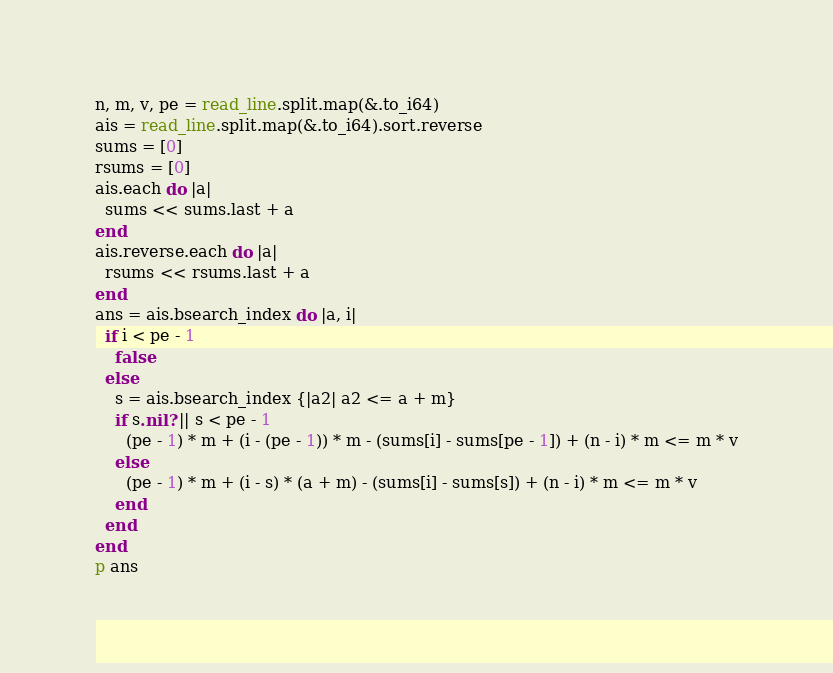<code> <loc_0><loc_0><loc_500><loc_500><_Crystal_>n, m, v, pe = read_line.split.map(&.to_i64)
ais = read_line.split.map(&.to_i64).sort.reverse
sums = [0]
rsums = [0]
ais.each do |a|
  sums << sums.last + a
end
ais.reverse.each do |a|
  rsums << rsums.last + a
end
ans = ais.bsearch_index do |a, i|
  if i < pe - 1
    false
  else
    s = ais.bsearch_index {|a2| a2 <= a + m}
    if s.nil? || s < pe - 1
      (pe - 1) * m + (i - (pe - 1)) * m - (sums[i] - sums[pe - 1]) + (n - i) * m <= m * v
    else
      (pe - 1) * m + (i - s) * (a + m) - (sums[i] - sums[s]) + (n - i) * m <= m * v
    end
  end
end
p ans</code> 